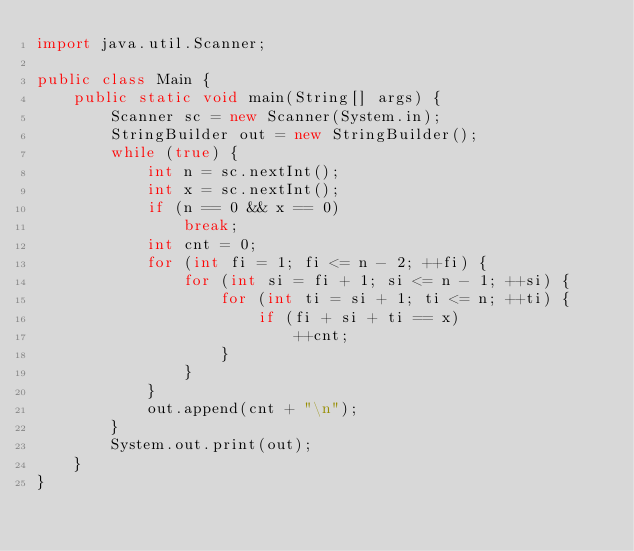<code> <loc_0><loc_0><loc_500><loc_500><_Java_>import java.util.Scanner;

public class Main {
	public static void main(String[] args) {
		Scanner sc = new Scanner(System.in);
		StringBuilder out = new StringBuilder();
		while (true) {
			int n = sc.nextInt();
			int x = sc.nextInt();
			if (n == 0 && x == 0)
				break;
			int cnt = 0;
			for (int fi = 1; fi <= n - 2; ++fi) {
				for (int si = fi + 1; si <= n - 1; ++si) {
					for (int ti = si + 1; ti <= n; ++ti) {
						if (fi + si + ti == x)
							++cnt;
					}
				}
			}
			out.append(cnt + "\n");
		}
		System.out.print(out);
	}
}
</code> 